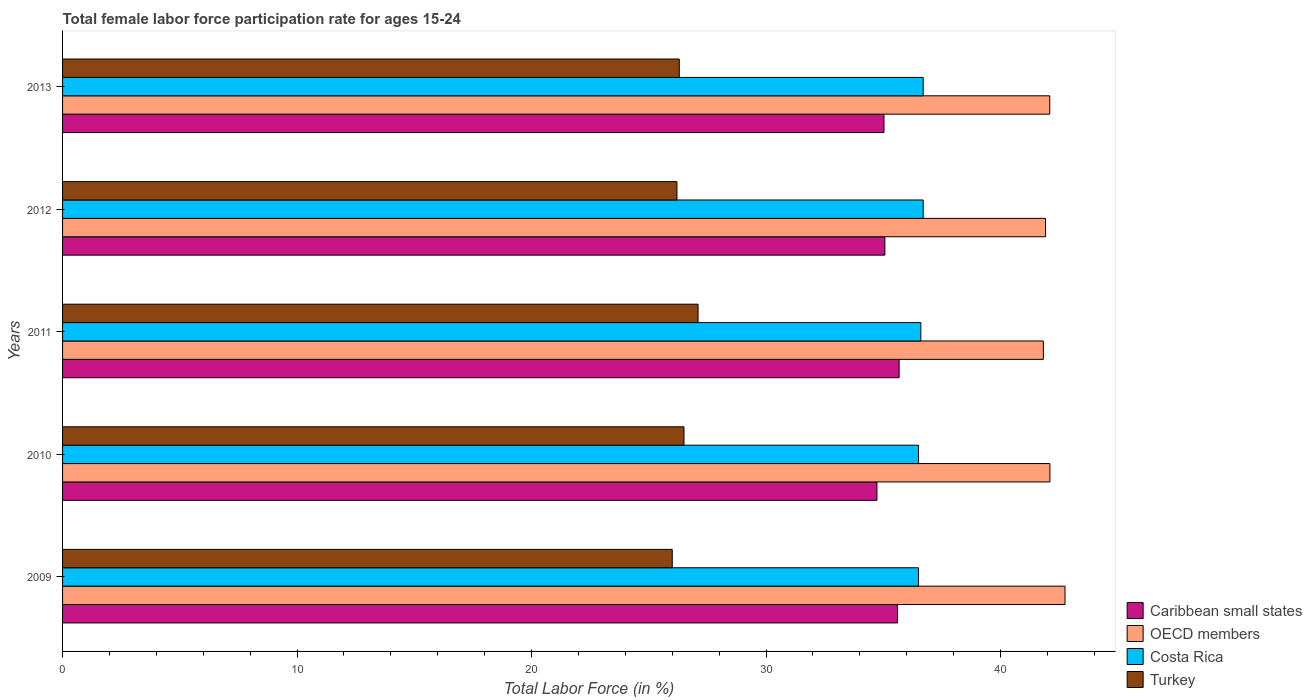How many different coloured bars are there?
Offer a very short reply. 4. Are the number of bars per tick equal to the number of legend labels?
Offer a very short reply. Yes. Are the number of bars on each tick of the Y-axis equal?
Provide a succinct answer. Yes. How many bars are there on the 2nd tick from the top?
Provide a short and direct response. 4. How many bars are there on the 5th tick from the bottom?
Provide a succinct answer. 4. What is the label of the 2nd group of bars from the top?
Make the answer very short. 2012. In how many cases, is the number of bars for a given year not equal to the number of legend labels?
Make the answer very short. 0. What is the female labor force participation rate in Costa Rica in 2013?
Make the answer very short. 36.7. Across all years, what is the maximum female labor force participation rate in OECD members?
Ensure brevity in your answer.  42.75. In which year was the female labor force participation rate in Caribbean small states maximum?
Make the answer very short. 2011. What is the total female labor force participation rate in Turkey in the graph?
Ensure brevity in your answer.  132.1. What is the difference between the female labor force participation rate in OECD members in 2009 and that in 2012?
Make the answer very short. 0.83. What is the difference between the female labor force participation rate in Caribbean small states in 2011 and the female labor force participation rate in Turkey in 2013?
Your answer should be compact. 9.37. What is the average female labor force participation rate in Costa Rica per year?
Your response must be concise. 36.6. In the year 2012, what is the difference between the female labor force participation rate in Turkey and female labor force participation rate in Costa Rica?
Make the answer very short. -10.5. What is the ratio of the female labor force participation rate in OECD members in 2009 to that in 2010?
Keep it short and to the point. 1.02. What is the difference between the highest and the lowest female labor force participation rate in OECD members?
Make the answer very short. 0.92. Is the sum of the female labor force participation rate in Caribbean small states in 2010 and 2012 greater than the maximum female labor force participation rate in Turkey across all years?
Offer a terse response. Yes. Is it the case that in every year, the sum of the female labor force participation rate in Caribbean small states and female labor force participation rate in Costa Rica is greater than the sum of female labor force participation rate in OECD members and female labor force participation rate in Turkey?
Give a very brief answer. No. What does the 1st bar from the top in 2012 represents?
Give a very brief answer. Turkey. What does the 2nd bar from the bottom in 2012 represents?
Provide a succinct answer. OECD members. How many bars are there?
Your answer should be compact. 20. Are all the bars in the graph horizontal?
Offer a terse response. Yes. How many years are there in the graph?
Make the answer very short. 5. What is the difference between two consecutive major ticks on the X-axis?
Give a very brief answer. 10. Are the values on the major ticks of X-axis written in scientific E-notation?
Make the answer very short. No. Does the graph contain any zero values?
Offer a very short reply. No. What is the title of the graph?
Keep it short and to the point. Total female labor force participation rate for ages 15-24. Does "Romania" appear as one of the legend labels in the graph?
Ensure brevity in your answer.  No. What is the label or title of the X-axis?
Give a very brief answer. Total Labor Force (in %). What is the Total Labor Force (in %) in Caribbean small states in 2009?
Make the answer very short. 35.61. What is the Total Labor Force (in %) of OECD members in 2009?
Offer a very short reply. 42.75. What is the Total Labor Force (in %) of Costa Rica in 2009?
Provide a short and direct response. 36.5. What is the Total Labor Force (in %) of Turkey in 2009?
Ensure brevity in your answer.  26. What is the Total Labor Force (in %) in Caribbean small states in 2010?
Give a very brief answer. 34.73. What is the Total Labor Force (in %) of OECD members in 2010?
Give a very brief answer. 42.1. What is the Total Labor Force (in %) in Costa Rica in 2010?
Make the answer very short. 36.5. What is the Total Labor Force (in %) in Caribbean small states in 2011?
Make the answer very short. 35.67. What is the Total Labor Force (in %) of OECD members in 2011?
Your answer should be very brief. 41.82. What is the Total Labor Force (in %) in Costa Rica in 2011?
Your response must be concise. 36.6. What is the Total Labor Force (in %) in Turkey in 2011?
Your answer should be compact. 27.1. What is the Total Labor Force (in %) in Caribbean small states in 2012?
Your answer should be compact. 35.07. What is the Total Labor Force (in %) of OECD members in 2012?
Keep it short and to the point. 41.92. What is the Total Labor Force (in %) in Costa Rica in 2012?
Keep it short and to the point. 36.7. What is the Total Labor Force (in %) of Turkey in 2012?
Offer a terse response. 26.2. What is the Total Labor Force (in %) of Caribbean small states in 2013?
Your response must be concise. 35.03. What is the Total Labor Force (in %) in OECD members in 2013?
Provide a short and direct response. 42.1. What is the Total Labor Force (in %) of Costa Rica in 2013?
Give a very brief answer. 36.7. What is the Total Labor Force (in %) in Turkey in 2013?
Your response must be concise. 26.3. Across all years, what is the maximum Total Labor Force (in %) in Caribbean small states?
Keep it short and to the point. 35.67. Across all years, what is the maximum Total Labor Force (in %) of OECD members?
Provide a short and direct response. 42.75. Across all years, what is the maximum Total Labor Force (in %) in Costa Rica?
Provide a succinct answer. 36.7. Across all years, what is the maximum Total Labor Force (in %) of Turkey?
Offer a very short reply. 27.1. Across all years, what is the minimum Total Labor Force (in %) in Caribbean small states?
Offer a terse response. 34.73. Across all years, what is the minimum Total Labor Force (in %) in OECD members?
Provide a short and direct response. 41.82. Across all years, what is the minimum Total Labor Force (in %) of Costa Rica?
Give a very brief answer. 36.5. Across all years, what is the minimum Total Labor Force (in %) of Turkey?
Your response must be concise. 26. What is the total Total Labor Force (in %) of Caribbean small states in the graph?
Give a very brief answer. 176.1. What is the total Total Labor Force (in %) of OECD members in the graph?
Keep it short and to the point. 210.69. What is the total Total Labor Force (in %) of Costa Rica in the graph?
Keep it short and to the point. 183. What is the total Total Labor Force (in %) in Turkey in the graph?
Your answer should be very brief. 132.1. What is the difference between the Total Labor Force (in %) in Caribbean small states in 2009 and that in 2010?
Give a very brief answer. 0.88. What is the difference between the Total Labor Force (in %) in OECD members in 2009 and that in 2010?
Your answer should be very brief. 0.64. What is the difference between the Total Labor Force (in %) of Caribbean small states in 2009 and that in 2011?
Give a very brief answer. -0.07. What is the difference between the Total Labor Force (in %) of OECD members in 2009 and that in 2011?
Offer a very short reply. 0.92. What is the difference between the Total Labor Force (in %) of Caribbean small states in 2009 and that in 2012?
Offer a terse response. 0.54. What is the difference between the Total Labor Force (in %) of OECD members in 2009 and that in 2012?
Your answer should be compact. 0.83. What is the difference between the Total Labor Force (in %) in Turkey in 2009 and that in 2012?
Offer a terse response. -0.2. What is the difference between the Total Labor Force (in %) in Caribbean small states in 2009 and that in 2013?
Give a very brief answer. 0.58. What is the difference between the Total Labor Force (in %) of OECD members in 2009 and that in 2013?
Your answer should be compact. 0.65. What is the difference between the Total Labor Force (in %) in Costa Rica in 2009 and that in 2013?
Offer a very short reply. -0.2. What is the difference between the Total Labor Force (in %) of Turkey in 2009 and that in 2013?
Keep it short and to the point. -0.3. What is the difference between the Total Labor Force (in %) in Caribbean small states in 2010 and that in 2011?
Your answer should be compact. -0.95. What is the difference between the Total Labor Force (in %) in OECD members in 2010 and that in 2011?
Offer a terse response. 0.28. What is the difference between the Total Labor Force (in %) of Caribbean small states in 2010 and that in 2012?
Offer a very short reply. -0.34. What is the difference between the Total Labor Force (in %) in OECD members in 2010 and that in 2012?
Provide a short and direct response. 0.19. What is the difference between the Total Labor Force (in %) in Caribbean small states in 2010 and that in 2013?
Keep it short and to the point. -0.3. What is the difference between the Total Labor Force (in %) in OECD members in 2010 and that in 2013?
Provide a succinct answer. 0.01. What is the difference between the Total Labor Force (in %) of Turkey in 2010 and that in 2013?
Ensure brevity in your answer.  0.2. What is the difference between the Total Labor Force (in %) in Caribbean small states in 2011 and that in 2012?
Offer a terse response. 0.61. What is the difference between the Total Labor Force (in %) of OECD members in 2011 and that in 2012?
Provide a succinct answer. -0.09. What is the difference between the Total Labor Force (in %) in Costa Rica in 2011 and that in 2012?
Keep it short and to the point. -0.1. What is the difference between the Total Labor Force (in %) of Turkey in 2011 and that in 2012?
Keep it short and to the point. 0.9. What is the difference between the Total Labor Force (in %) in Caribbean small states in 2011 and that in 2013?
Keep it short and to the point. 0.65. What is the difference between the Total Labor Force (in %) in OECD members in 2011 and that in 2013?
Provide a short and direct response. -0.27. What is the difference between the Total Labor Force (in %) in Costa Rica in 2011 and that in 2013?
Offer a very short reply. -0.1. What is the difference between the Total Labor Force (in %) in Caribbean small states in 2012 and that in 2013?
Ensure brevity in your answer.  0.04. What is the difference between the Total Labor Force (in %) in OECD members in 2012 and that in 2013?
Offer a terse response. -0.18. What is the difference between the Total Labor Force (in %) of Costa Rica in 2012 and that in 2013?
Make the answer very short. 0. What is the difference between the Total Labor Force (in %) of Turkey in 2012 and that in 2013?
Ensure brevity in your answer.  -0.1. What is the difference between the Total Labor Force (in %) of Caribbean small states in 2009 and the Total Labor Force (in %) of OECD members in 2010?
Offer a very short reply. -6.5. What is the difference between the Total Labor Force (in %) of Caribbean small states in 2009 and the Total Labor Force (in %) of Costa Rica in 2010?
Offer a terse response. -0.89. What is the difference between the Total Labor Force (in %) of Caribbean small states in 2009 and the Total Labor Force (in %) of Turkey in 2010?
Provide a succinct answer. 9.11. What is the difference between the Total Labor Force (in %) of OECD members in 2009 and the Total Labor Force (in %) of Costa Rica in 2010?
Provide a succinct answer. 6.25. What is the difference between the Total Labor Force (in %) of OECD members in 2009 and the Total Labor Force (in %) of Turkey in 2010?
Provide a short and direct response. 16.25. What is the difference between the Total Labor Force (in %) in Costa Rica in 2009 and the Total Labor Force (in %) in Turkey in 2010?
Provide a short and direct response. 10. What is the difference between the Total Labor Force (in %) of Caribbean small states in 2009 and the Total Labor Force (in %) of OECD members in 2011?
Give a very brief answer. -6.22. What is the difference between the Total Labor Force (in %) in Caribbean small states in 2009 and the Total Labor Force (in %) in Costa Rica in 2011?
Keep it short and to the point. -0.99. What is the difference between the Total Labor Force (in %) of Caribbean small states in 2009 and the Total Labor Force (in %) of Turkey in 2011?
Make the answer very short. 8.51. What is the difference between the Total Labor Force (in %) in OECD members in 2009 and the Total Labor Force (in %) in Costa Rica in 2011?
Offer a terse response. 6.15. What is the difference between the Total Labor Force (in %) in OECD members in 2009 and the Total Labor Force (in %) in Turkey in 2011?
Provide a short and direct response. 15.65. What is the difference between the Total Labor Force (in %) of Caribbean small states in 2009 and the Total Labor Force (in %) of OECD members in 2012?
Provide a short and direct response. -6.31. What is the difference between the Total Labor Force (in %) of Caribbean small states in 2009 and the Total Labor Force (in %) of Costa Rica in 2012?
Make the answer very short. -1.09. What is the difference between the Total Labor Force (in %) in Caribbean small states in 2009 and the Total Labor Force (in %) in Turkey in 2012?
Make the answer very short. 9.41. What is the difference between the Total Labor Force (in %) in OECD members in 2009 and the Total Labor Force (in %) in Costa Rica in 2012?
Offer a very short reply. 6.05. What is the difference between the Total Labor Force (in %) in OECD members in 2009 and the Total Labor Force (in %) in Turkey in 2012?
Offer a terse response. 16.55. What is the difference between the Total Labor Force (in %) in Caribbean small states in 2009 and the Total Labor Force (in %) in OECD members in 2013?
Offer a terse response. -6.49. What is the difference between the Total Labor Force (in %) in Caribbean small states in 2009 and the Total Labor Force (in %) in Costa Rica in 2013?
Provide a short and direct response. -1.09. What is the difference between the Total Labor Force (in %) of Caribbean small states in 2009 and the Total Labor Force (in %) of Turkey in 2013?
Offer a terse response. 9.31. What is the difference between the Total Labor Force (in %) in OECD members in 2009 and the Total Labor Force (in %) in Costa Rica in 2013?
Ensure brevity in your answer.  6.05. What is the difference between the Total Labor Force (in %) of OECD members in 2009 and the Total Labor Force (in %) of Turkey in 2013?
Make the answer very short. 16.45. What is the difference between the Total Labor Force (in %) in Costa Rica in 2009 and the Total Labor Force (in %) in Turkey in 2013?
Give a very brief answer. 10.2. What is the difference between the Total Labor Force (in %) in Caribbean small states in 2010 and the Total Labor Force (in %) in OECD members in 2011?
Your answer should be very brief. -7.1. What is the difference between the Total Labor Force (in %) of Caribbean small states in 2010 and the Total Labor Force (in %) of Costa Rica in 2011?
Provide a short and direct response. -1.87. What is the difference between the Total Labor Force (in %) in Caribbean small states in 2010 and the Total Labor Force (in %) in Turkey in 2011?
Offer a terse response. 7.63. What is the difference between the Total Labor Force (in %) of OECD members in 2010 and the Total Labor Force (in %) of Costa Rica in 2011?
Your response must be concise. 5.5. What is the difference between the Total Labor Force (in %) in OECD members in 2010 and the Total Labor Force (in %) in Turkey in 2011?
Keep it short and to the point. 15. What is the difference between the Total Labor Force (in %) of Costa Rica in 2010 and the Total Labor Force (in %) of Turkey in 2011?
Your answer should be very brief. 9.4. What is the difference between the Total Labor Force (in %) in Caribbean small states in 2010 and the Total Labor Force (in %) in OECD members in 2012?
Your response must be concise. -7.19. What is the difference between the Total Labor Force (in %) of Caribbean small states in 2010 and the Total Labor Force (in %) of Costa Rica in 2012?
Provide a succinct answer. -1.97. What is the difference between the Total Labor Force (in %) of Caribbean small states in 2010 and the Total Labor Force (in %) of Turkey in 2012?
Your response must be concise. 8.53. What is the difference between the Total Labor Force (in %) of OECD members in 2010 and the Total Labor Force (in %) of Costa Rica in 2012?
Provide a short and direct response. 5.4. What is the difference between the Total Labor Force (in %) of OECD members in 2010 and the Total Labor Force (in %) of Turkey in 2012?
Make the answer very short. 15.9. What is the difference between the Total Labor Force (in %) of Costa Rica in 2010 and the Total Labor Force (in %) of Turkey in 2012?
Keep it short and to the point. 10.3. What is the difference between the Total Labor Force (in %) of Caribbean small states in 2010 and the Total Labor Force (in %) of OECD members in 2013?
Make the answer very short. -7.37. What is the difference between the Total Labor Force (in %) of Caribbean small states in 2010 and the Total Labor Force (in %) of Costa Rica in 2013?
Give a very brief answer. -1.97. What is the difference between the Total Labor Force (in %) in Caribbean small states in 2010 and the Total Labor Force (in %) in Turkey in 2013?
Offer a very short reply. 8.43. What is the difference between the Total Labor Force (in %) of OECD members in 2010 and the Total Labor Force (in %) of Costa Rica in 2013?
Provide a short and direct response. 5.4. What is the difference between the Total Labor Force (in %) in OECD members in 2010 and the Total Labor Force (in %) in Turkey in 2013?
Provide a succinct answer. 15.8. What is the difference between the Total Labor Force (in %) in Caribbean small states in 2011 and the Total Labor Force (in %) in OECD members in 2012?
Make the answer very short. -6.24. What is the difference between the Total Labor Force (in %) in Caribbean small states in 2011 and the Total Labor Force (in %) in Costa Rica in 2012?
Your response must be concise. -1.03. What is the difference between the Total Labor Force (in %) in Caribbean small states in 2011 and the Total Labor Force (in %) in Turkey in 2012?
Give a very brief answer. 9.47. What is the difference between the Total Labor Force (in %) in OECD members in 2011 and the Total Labor Force (in %) in Costa Rica in 2012?
Your answer should be compact. 5.12. What is the difference between the Total Labor Force (in %) in OECD members in 2011 and the Total Labor Force (in %) in Turkey in 2012?
Give a very brief answer. 15.62. What is the difference between the Total Labor Force (in %) in Caribbean small states in 2011 and the Total Labor Force (in %) in OECD members in 2013?
Ensure brevity in your answer.  -6.42. What is the difference between the Total Labor Force (in %) of Caribbean small states in 2011 and the Total Labor Force (in %) of Costa Rica in 2013?
Offer a very short reply. -1.03. What is the difference between the Total Labor Force (in %) in Caribbean small states in 2011 and the Total Labor Force (in %) in Turkey in 2013?
Ensure brevity in your answer.  9.37. What is the difference between the Total Labor Force (in %) of OECD members in 2011 and the Total Labor Force (in %) of Costa Rica in 2013?
Your response must be concise. 5.12. What is the difference between the Total Labor Force (in %) of OECD members in 2011 and the Total Labor Force (in %) of Turkey in 2013?
Offer a very short reply. 15.52. What is the difference between the Total Labor Force (in %) in Costa Rica in 2011 and the Total Labor Force (in %) in Turkey in 2013?
Your answer should be compact. 10.3. What is the difference between the Total Labor Force (in %) in Caribbean small states in 2012 and the Total Labor Force (in %) in OECD members in 2013?
Provide a short and direct response. -7.03. What is the difference between the Total Labor Force (in %) of Caribbean small states in 2012 and the Total Labor Force (in %) of Costa Rica in 2013?
Keep it short and to the point. -1.63. What is the difference between the Total Labor Force (in %) of Caribbean small states in 2012 and the Total Labor Force (in %) of Turkey in 2013?
Give a very brief answer. 8.77. What is the difference between the Total Labor Force (in %) in OECD members in 2012 and the Total Labor Force (in %) in Costa Rica in 2013?
Ensure brevity in your answer.  5.22. What is the difference between the Total Labor Force (in %) of OECD members in 2012 and the Total Labor Force (in %) of Turkey in 2013?
Make the answer very short. 15.62. What is the difference between the Total Labor Force (in %) in Costa Rica in 2012 and the Total Labor Force (in %) in Turkey in 2013?
Provide a short and direct response. 10.4. What is the average Total Labor Force (in %) of Caribbean small states per year?
Provide a succinct answer. 35.22. What is the average Total Labor Force (in %) in OECD members per year?
Give a very brief answer. 42.14. What is the average Total Labor Force (in %) of Costa Rica per year?
Give a very brief answer. 36.6. What is the average Total Labor Force (in %) in Turkey per year?
Provide a succinct answer. 26.42. In the year 2009, what is the difference between the Total Labor Force (in %) in Caribbean small states and Total Labor Force (in %) in OECD members?
Your answer should be compact. -7.14. In the year 2009, what is the difference between the Total Labor Force (in %) of Caribbean small states and Total Labor Force (in %) of Costa Rica?
Give a very brief answer. -0.89. In the year 2009, what is the difference between the Total Labor Force (in %) of Caribbean small states and Total Labor Force (in %) of Turkey?
Keep it short and to the point. 9.61. In the year 2009, what is the difference between the Total Labor Force (in %) in OECD members and Total Labor Force (in %) in Costa Rica?
Offer a very short reply. 6.25. In the year 2009, what is the difference between the Total Labor Force (in %) in OECD members and Total Labor Force (in %) in Turkey?
Provide a short and direct response. 16.75. In the year 2010, what is the difference between the Total Labor Force (in %) of Caribbean small states and Total Labor Force (in %) of OECD members?
Your response must be concise. -7.38. In the year 2010, what is the difference between the Total Labor Force (in %) in Caribbean small states and Total Labor Force (in %) in Costa Rica?
Offer a very short reply. -1.77. In the year 2010, what is the difference between the Total Labor Force (in %) in Caribbean small states and Total Labor Force (in %) in Turkey?
Keep it short and to the point. 8.23. In the year 2010, what is the difference between the Total Labor Force (in %) in OECD members and Total Labor Force (in %) in Costa Rica?
Give a very brief answer. 5.6. In the year 2010, what is the difference between the Total Labor Force (in %) of OECD members and Total Labor Force (in %) of Turkey?
Keep it short and to the point. 15.6. In the year 2010, what is the difference between the Total Labor Force (in %) of Costa Rica and Total Labor Force (in %) of Turkey?
Ensure brevity in your answer.  10. In the year 2011, what is the difference between the Total Labor Force (in %) in Caribbean small states and Total Labor Force (in %) in OECD members?
Provide a short and direct response. -6.15. In the year 2011, what is the difference between the Total Labor Force (in %) in Caribbean small states and Total Labor Force (in %) in Costa Rica?
Provide a short and direct response. -0.93. In the year 2011, what is the difference between the Total Labor Force (in %) in Caribbean small states and Total Labor Force (in %) in Turkey?
Your response must be concise. 8.57. In the year 2011, what is the difference between the Total Labor Force (in %) of OECD members and Total Labor Force (in %) of Costa Rica?
Make the answer very short. 5.22. In the year 2011, what is the difference between the Total Labor Force (in %) in OECD members and Total Labor Force (in %) in Turkey?
Provide a short and direct response. 14.72. In the year 2011, what is the difference between the Total Labor Force (in %) of Costa Rica and Total Labor Force (in %) of Turkey?
Offer a terse response. 9.5. In the year 2012, what is the difference between the Total Labor Force (in %) in Caribbean small states and Total Labor Force (in %) in OECD members?
Offer a terse response. -6.85. In the year 2012, what is the difference between the Total Labor Force (in %) in Caribbean small states and Total Labor Force (in %) in Costa Rica?
Provide a short and direct response. -1.63. In the year 2012, what is the difference between the Total Labor Force (in %) in Caribbean small states and Total Labor Force (in %) in Turkey?
Your response must be concise. 8.87. In the year 2012, what is the difference between the Total Labor Force (in %) in OECD members and Total Labor Force (in %) in Costa Rica?
Offer a very short reply. 5.22. In the year 2012, what is the difference between the Total Labor Force (in %) in OECD members and Total Labor Force (in %) in Turkey?
Provide a succinct answer. 15.72. In the year 2013, what is the difference between the Total Labor Force (in %) of Caribbean small states and Total Labor Force (in %) of OECD members?
Ensure brevity in your answer.  -7.07. In the year 2013, what is the difference between the Total Labor Force (in %) of Caribbean small states and Total Labor Force (in %) of Costa Rica?
Provide a short and direct response. -1.67. In the year 2013, what is the difference between the Total Labor Force (in %) of Caribbean small states and Total Labor Force (in %) of Turkey?
Give a very brief answer. 8.73. In the year 2013, what is the difference between the Total Labor Force (in %) of OECD members and Total Labor Force (in %) of Costa Rica?
Keep it short and to the point. 5.4. In the year 2013, what is the difference between the Total Labor Force (in %) in OECD members and Total Labor Force (in %) in Turkey?
Provide a short and direct response. 15.8. In the year 2013, what is the difference between the Total Labor Force (in %) of Costa Rica and Total Labor Force (in %) of Turkey?
Give a very brief answer. 10.4. What is the ratio of the Total Labor Force (in %) in Caribbean small states in 2009 to that in 2010?
Provide a succinct answer. 1.03. What is the ratio of the Total Labor Force (in %) in OECD members in 2009 to that in 2010?
Offer a terse response. 1.02. What is the ratio of the Total Labor Force (in %) in Costa Rica in 2009 to that in 2010?
Your answer should be very brief. 1. What is the ratio of the Total Labor Force (in %) of Turkey in 2009 to that in 2010?
Offer a very short reply. 0.98. What is the ratio of the Total Labor Force (in %) in OECD members in 2009 to that in 2011?
Offer a very short reply. 1.02. What is the ratio of the Total Labor Force (in %) in Turkey in 2009 to that in 2011?
Provide a succinct answer. 0.96. What is the ratio of the Total Labor Force (in %) of Caribbean small states in 2009 to that in 2012?
Give a very brief answer. 1.02. What is the ratio of the Total Labor Force (in %) of OECD members in 2009 to that in 2012?
Your answer should be compact. 1.02. What is the ratio of the Total Labor Force (in %) of Caribbean small states in 2009 to that in 2013?
Provide a short and direct response. 1.02. What is the ratio of the Total Labor Force (in %) of OECD members in 2009 to that in 2013?
Your response must be concise. 1.02. What is the ratio of the Total Labor Force (in %) in Costa Rica in 2009 to that in 2013?
Provide a short and direct response. 0.99. What is the ratio of the Total Labor Force (in %) in Turkey in 2009 to that in 2013?
Your response must be concise. 0.99. What is the ratio of the Total Labor Force (in %) of Caribbean small states in 2010 to that in 2011?
Ensure brevity in your answer.  0.97. What is the ratio of the Total Labor Force (in %) of Costa Rica in 2010 to that in 2011?
Offer a very short reply. 1. What is the ratio of the Total Labor Force (in %) in Turkey in 2010 to that in 2011?
Offer a very short reply. 0.98. What is the ratio of the Total Labor Force (in %) of Costa Rica in 2010 to that in 2012?
Provide a short and direct response. 0.99. What is the ratio of the Total Labor Force (in %) of Turkey in 2010 to that in 2012?
Make the answer very short. 1.01. What is the ratio of the Total Labor Force (in %) of Caribbean small states in 2010 to that in 2013?
Offer a terse response. 0.99. What is the ratio of the Total Labor Force (in %) in Costa Rica in 2010 to that in 2013?
Provide a succinct answer. 0.99. What is the ratio of the Total Labor Force (in %) in Turkey in 2010 to that in 2013?
Your answer should be very brief. 1.01. What is the ratio of the Total Labor Force (in %) in Caribbean small states in 2011 to that in 2012?
Provide a succinct answer. 1.02. What is the ratio of the Total Labor Force (in %) of Costa Rica in 2011 to that in 2012?
Provide a short and direct response. 1. What is the ratio of the Total Labor Force (in %) in Turkey in 2011 to that in 2012?
Keep it short and to the point. 1.03. What is the ratio of the Total Labor Force (in %) of Caribbean small states in 2011 to that in 2013?
Make the answer very short. 1.02. What is the ratio of the Total Labor Force (in %) in Turkey in 2011 to that in 2013?
Keep it short and to the point. 1.03. What is the ratio of the Total Labor Force (in %) of Caribbean small states in 2012 to that in 2013?
Make the answer very short. 1. What is the ratio of the Total Labor Force (in %) of Turkey in 2012 to that in 2013?
Offer a terse response. 1. What is the difference between the highest and the second highest Total Labor Force (in %) in Caribbean small states?
Ensure brevity in your answer.  0.07. What is the difference between the highest and the second highest Total Labor Force (in %) of OECD members?
Your response must be concise. 0.64. What is the difference between the highest and the second highest Total Labor Force (in %) of Turkey?
Offer a terse response. 0.6. What is the difference between the highest and the lowest Total Labor Force (in %) in Caribbean small states?
Keep it short and to the point. 0.95. What is the difference between the highest and the lowest Total Labor Force (in %) of OECD members?
Ensure brevity in your answer.  0.92. 